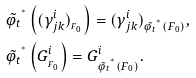Convert formula to latex. <formula><loc_0><loc_0><loc_500><loc_500>& \tilde { \varphi _ { t } } ^ { ^ { * } } \left ( ( \gamma ^ { i } _ { j k } ) _ { _ { F _ { 0 } } } \right ) = ( \gamma ^ { i } _ { j k } ) _ { \tilde { \varphi _ { t } } ^ { ^ { * } } ( F _ { 0 } ) } , \\ & \tilde { \varphi _ { t } } ^ { ^ { * } } \left ( G ^ { i } _ { _ { F _ { 0 } } } \right ) = G ^ { i } _ { \tilde { \varphi _ { t } } ^ { ^ { * } } ( F _ { 0 } ) } .</formula> 